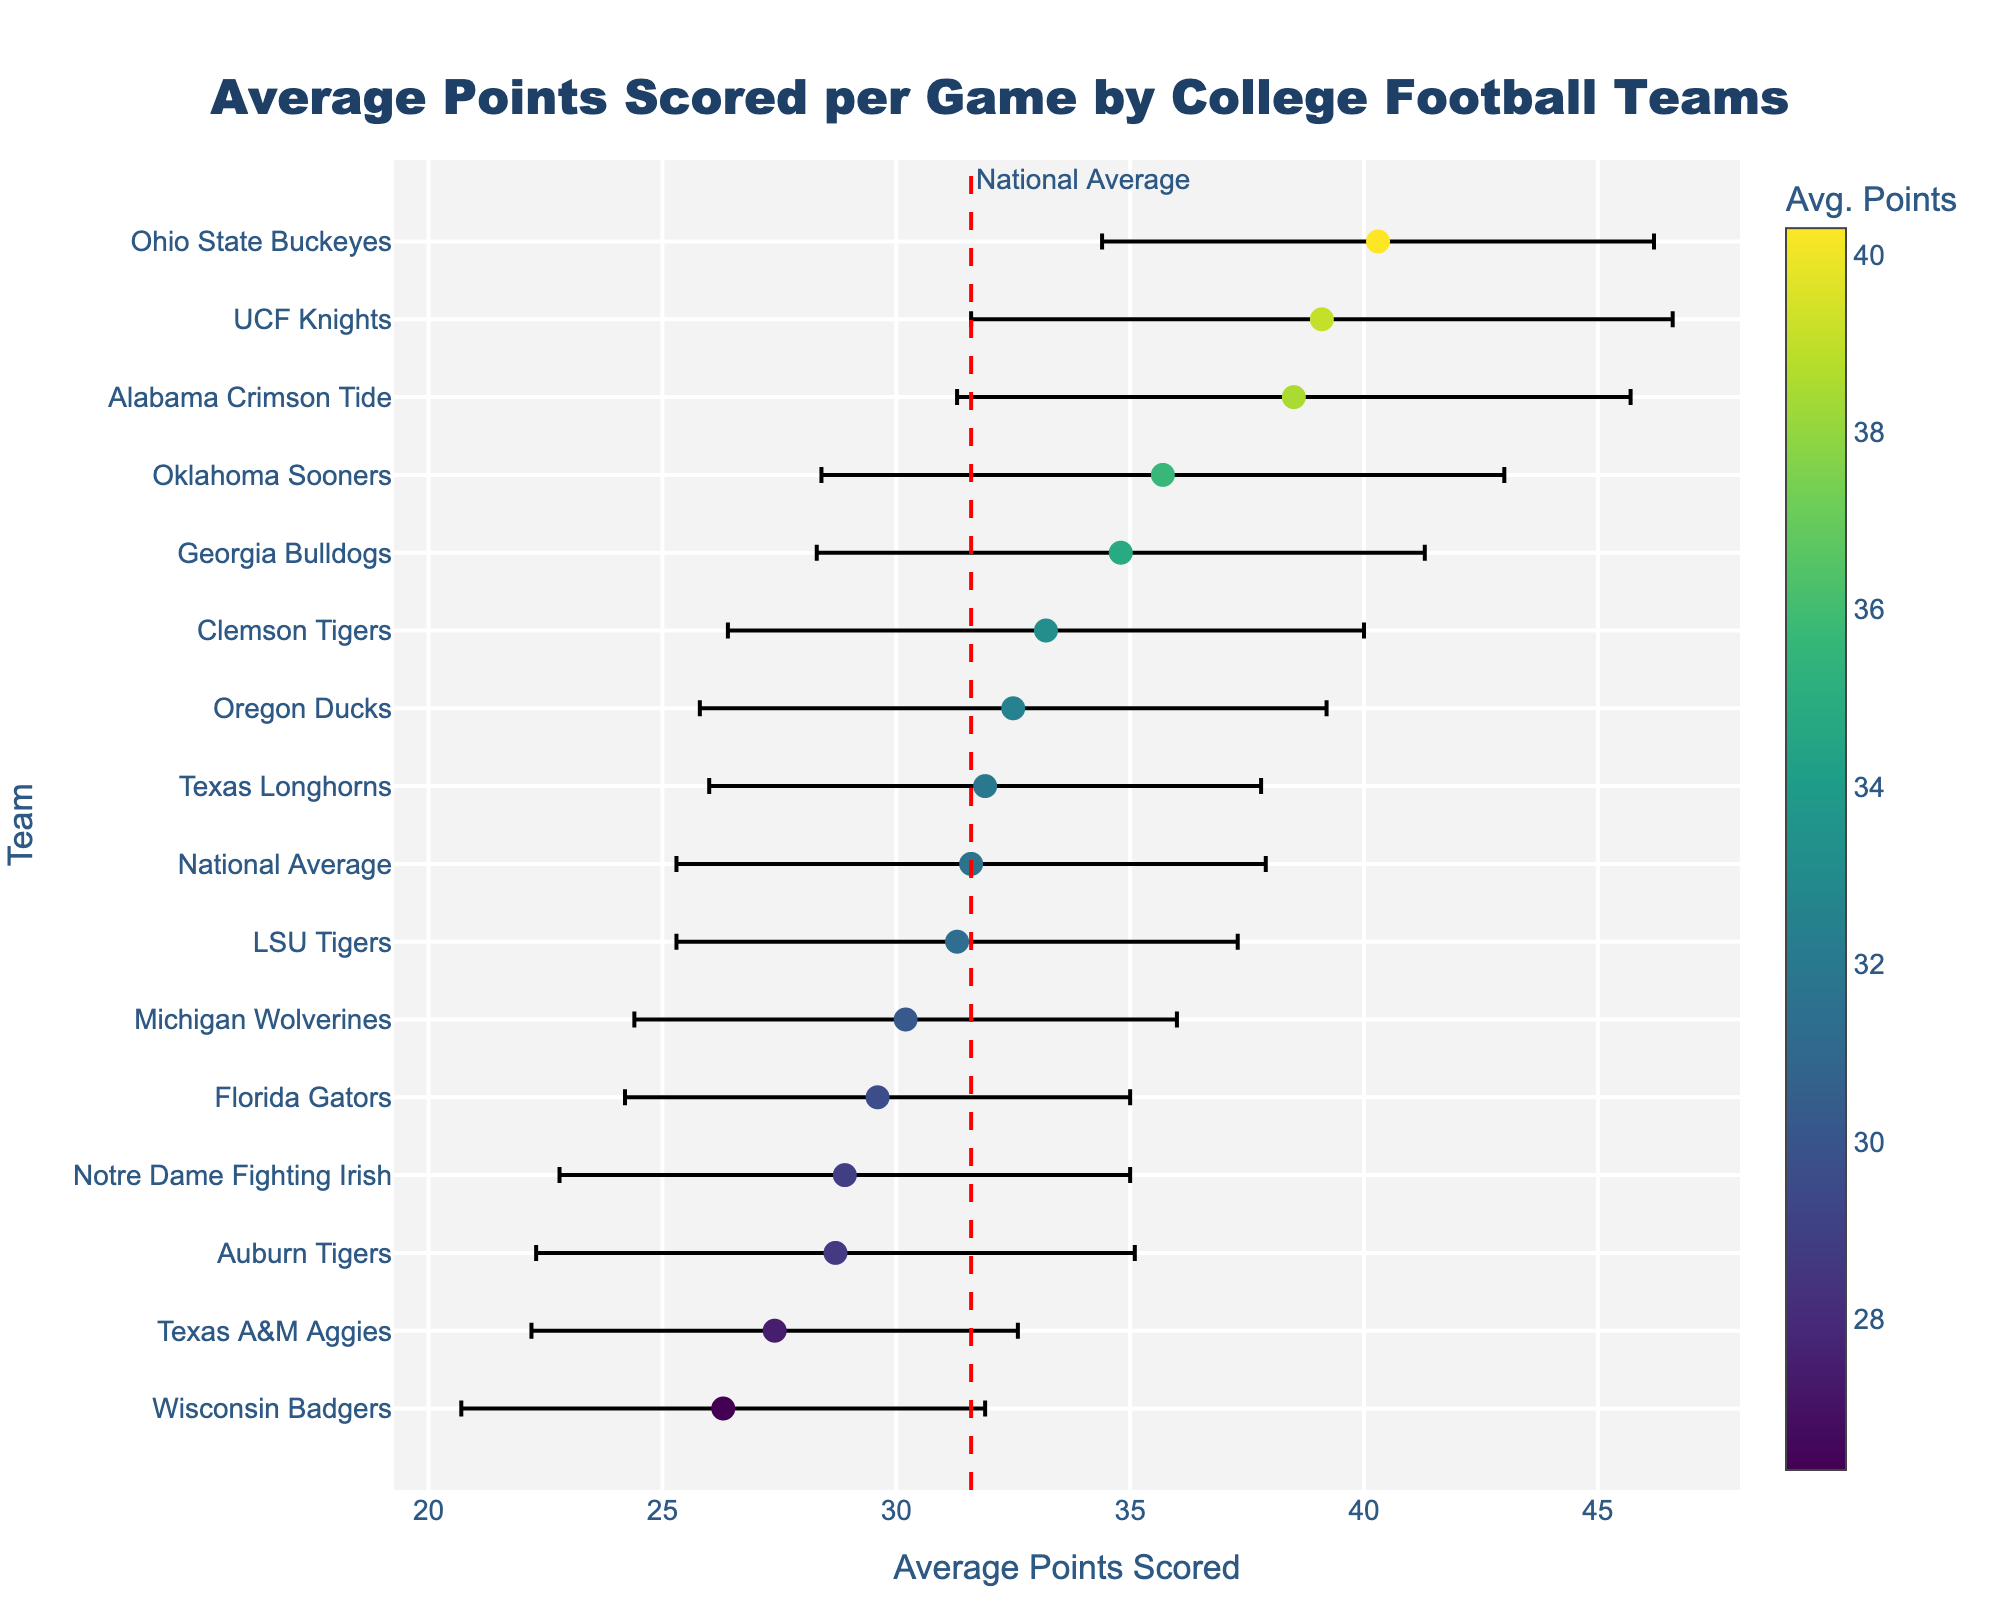What's the title of the figure? The title is located at the top center of the figure and usually provides a brief description of the data being presented. In this case, it is "Average Points Scored per Game by College Football Teams".
Answer: Average Points Scored per Game by College Football Teams How many teams scored above the national average? First, find the national average score (31.6 points). Then count the number of teams whose average points scored are greater than 31.6.
Answer: 8 Which team has the highest average points scored per game? Look for the team with the highest dot on the x-axis. The team with the highest average points is indicated by the furthest point to the right.
Answer: Ohio State Buckeyes What is the average difference in points scored per game between the Ohio State Buckeyes and the Florida Gators? Subtract the average points scored by Florida Gators (29.6) from the average points scored by Ohio State Buckeyes (40.3).
Answer: 10.7 points Which team has the largest standard deviation in points scored? The team with the largest error bar (horizontal line) indicates the largest standard deviation. The largest error bar belongs to the UCF Knights.
Answer: UCF Knights Which teams scored below the national average? Identify teams with average points scored less than the national average (31.6). Look for dots to the left of the vertical red dashed line. These teams include Texas A&M Aggies, Notre Dame Fighting Irish, Auburn Tigers, and Wisconsin Badgers.
Answer: Texas A&M Aggies, Notre Dame Fighting Irish, Auburn Tigers, Wisconsin Badgers How does the standard deviation of the Alabama Crimson Tide compare to the Georgia Bulldogs? Find the length of the error bars for both teams. Alabama Crimson Tide has a standard deviation of 7.2, and Georgia Bulldogs have a standard deviation of 6.5. Compare the two values.
Answer: Alabama Crimson Tide has a larger standard deviation Which team has the smallest average points scored per game, and what is the value? Look for the team with the lowest dot on the x-axis, which represents the smallest average points scored.
Answer: Wisconsin Badgers, 26.3 points What is the approximate visual range of average points scored per game for the Ohio State Buckeyes considering their standard deviation? The average points scored by Ohio State Buckeyes is 40.3, with a standard deviation of 5.9. The range is about 40.3 ± 5.9 (from ~34.4 to ~46.2).
Answer: ~34.4 to ~46.2 points 